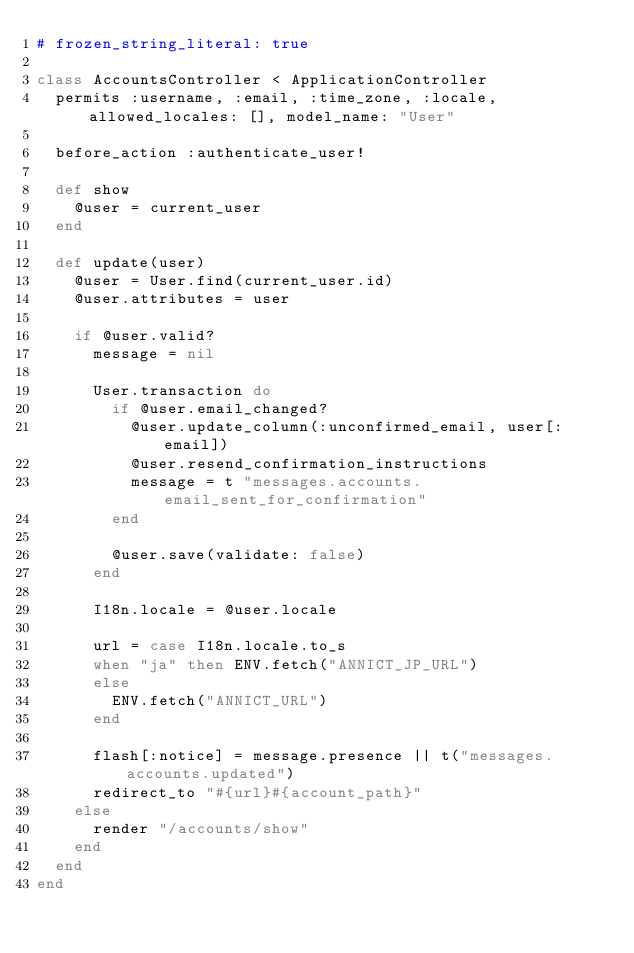<code> <loc_0><loc_0><loc_500><loc_500><_Ruby_># frozen_string_literal: true

class AccountsController < ApplicationController
  permits :username, :email, :time_zone, :locale, allowed_locales: [], model_name: "User"

  before_action :authenticate_user!

  def show
    @user = current_user
  end

  def update(user)
    @user = User.find(current_user.id)
    @user.attributes = user

    if @user.valid?
      message = nil

      User.transaction do
        if @user.email_changed?
          @user.update_column(:unconfirmed_email, user[:email])
          @user.resend_confirmation_instructions
          message = t "messages.accounts.email_sent_for_confirmation"
        end

        @user.save(validate: false)
      end

      I18n.locale = @user.locale

      url = case I18n.locale.to_s
      when "ja" then ENV.fetch("ANNICT_JP_URL")
      else
        ENV.fetch("ANNICT_URL")
      end

      flash[:notice] = message.presence || t("messages.accounts.updated")
      redirect_to "#{url}#{account_path}"
    else
      render "/accounts/show"
    end
  end
end
</code> 